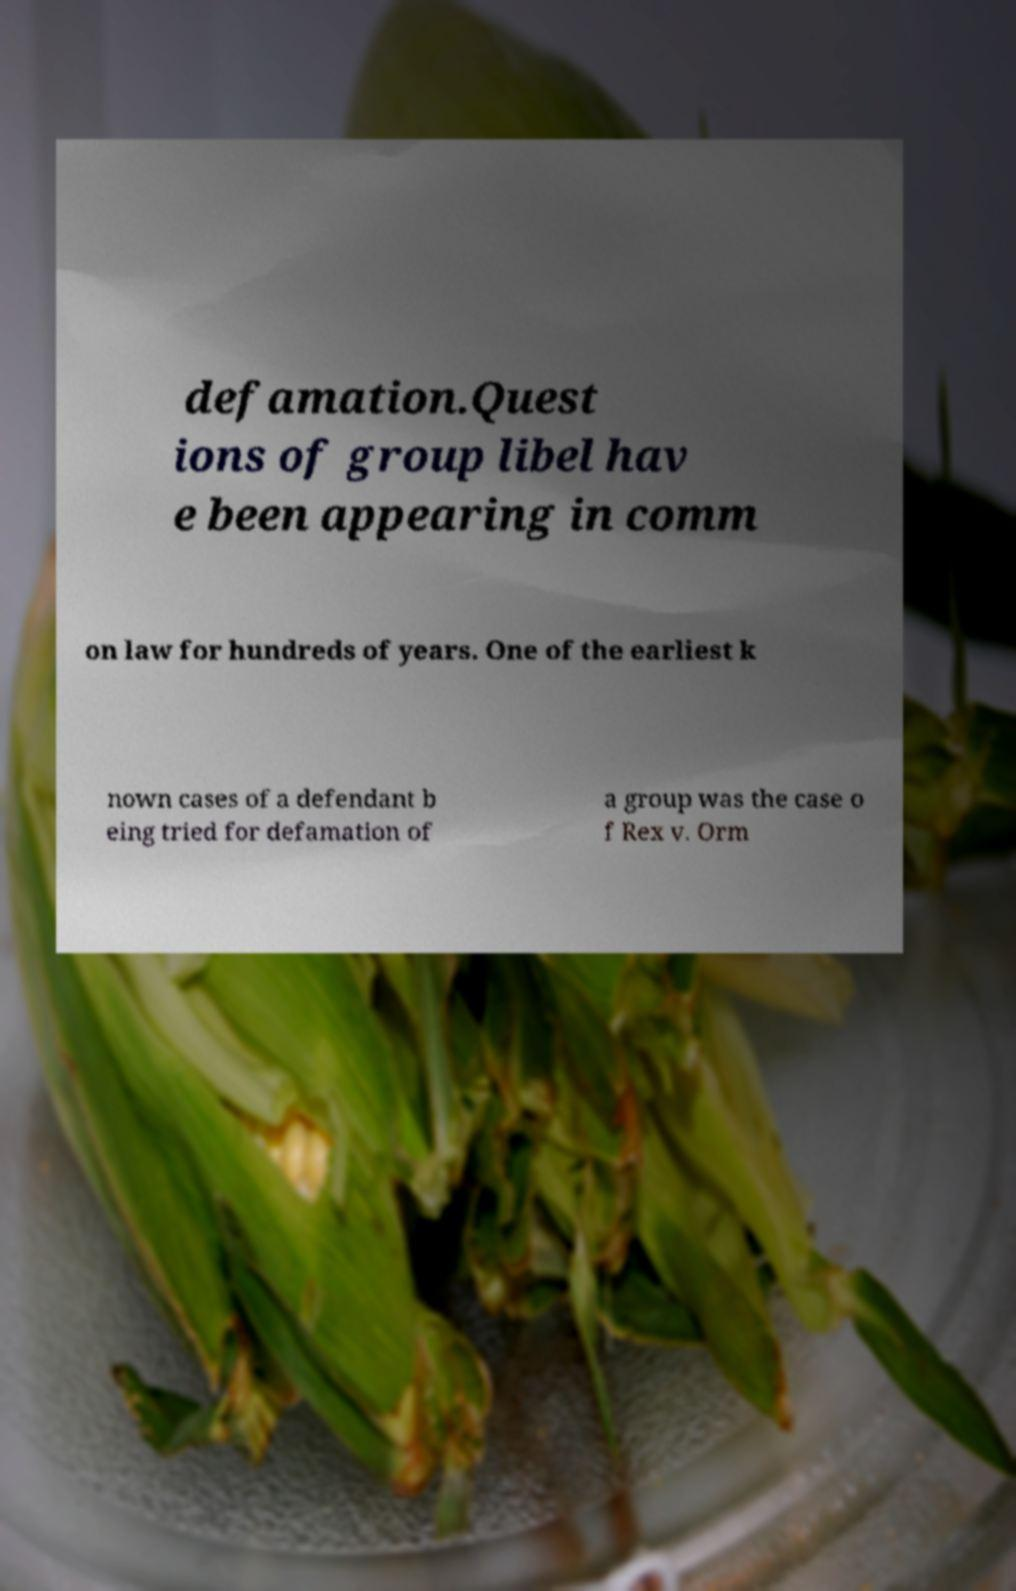Please identify and transcribe the text found in this image. defamation.Quest ions of group libel hav e been appearing in comm on law for hundreds of years. One of the earliest k nown cases of a defendant b eing tried for defamation of a group was the case o f Rex v. Orm 